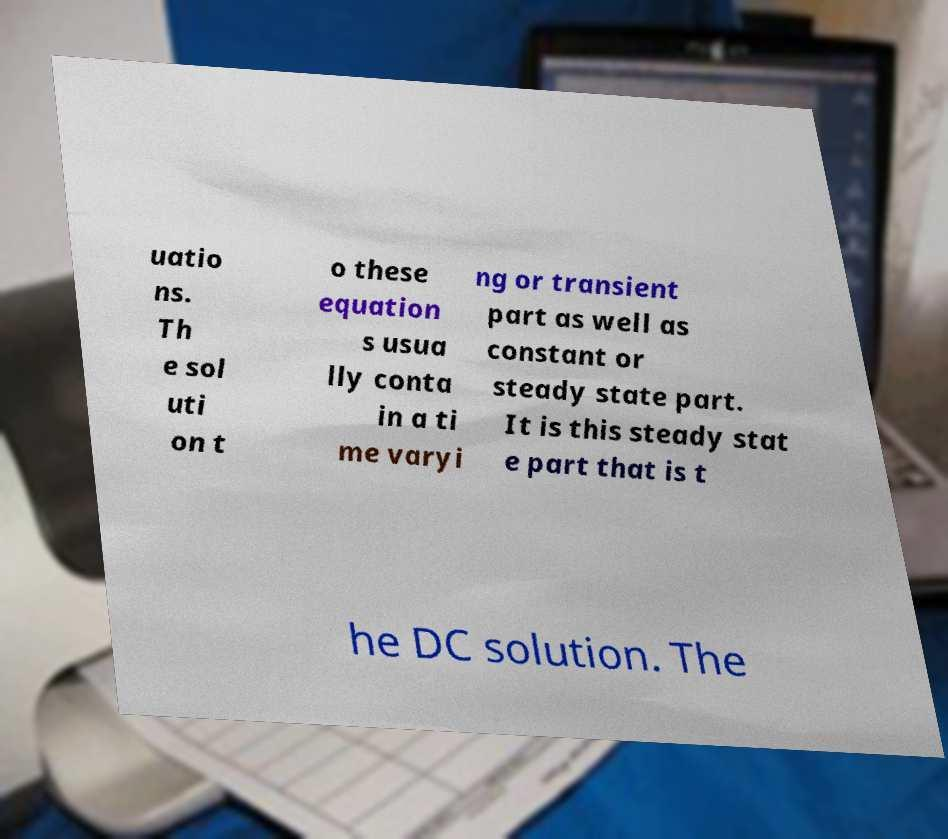There's text embedded in this image that I need extracted. Can you transcribe it verbatim? uatio ns. Th e sol uti on t o these equation s usua lly conta in a ti me varyi ng or transient part as well as constant or steady state part. It is this steady stat e part that is t he DC solution. The 